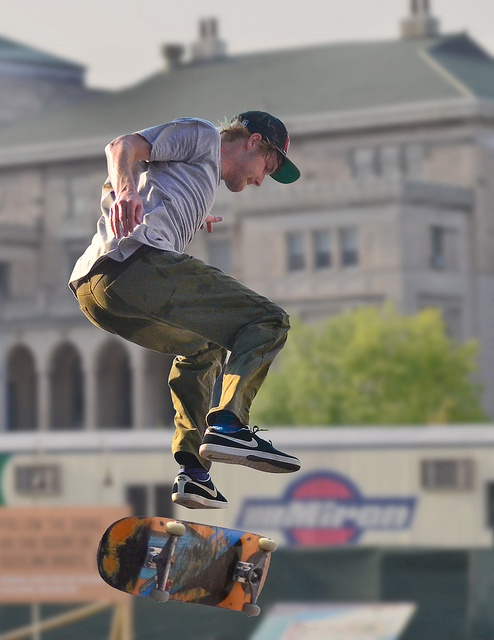Describe the objects in this image and their specific colors. I can see people in lightgray, black, gray, and darkgray tones and skateboard in lightgray, black, gray, maroon, and brown tones in this image. 